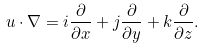Convert formula to latex. <formula><loc_0><loc_0><loc_500><loc_500>u \cdot \nabla = i \frac { \partial } { \partial x } + j \frac { \partial } { \partial y } + k \frac { \partial } { \partial z } .</formula> 